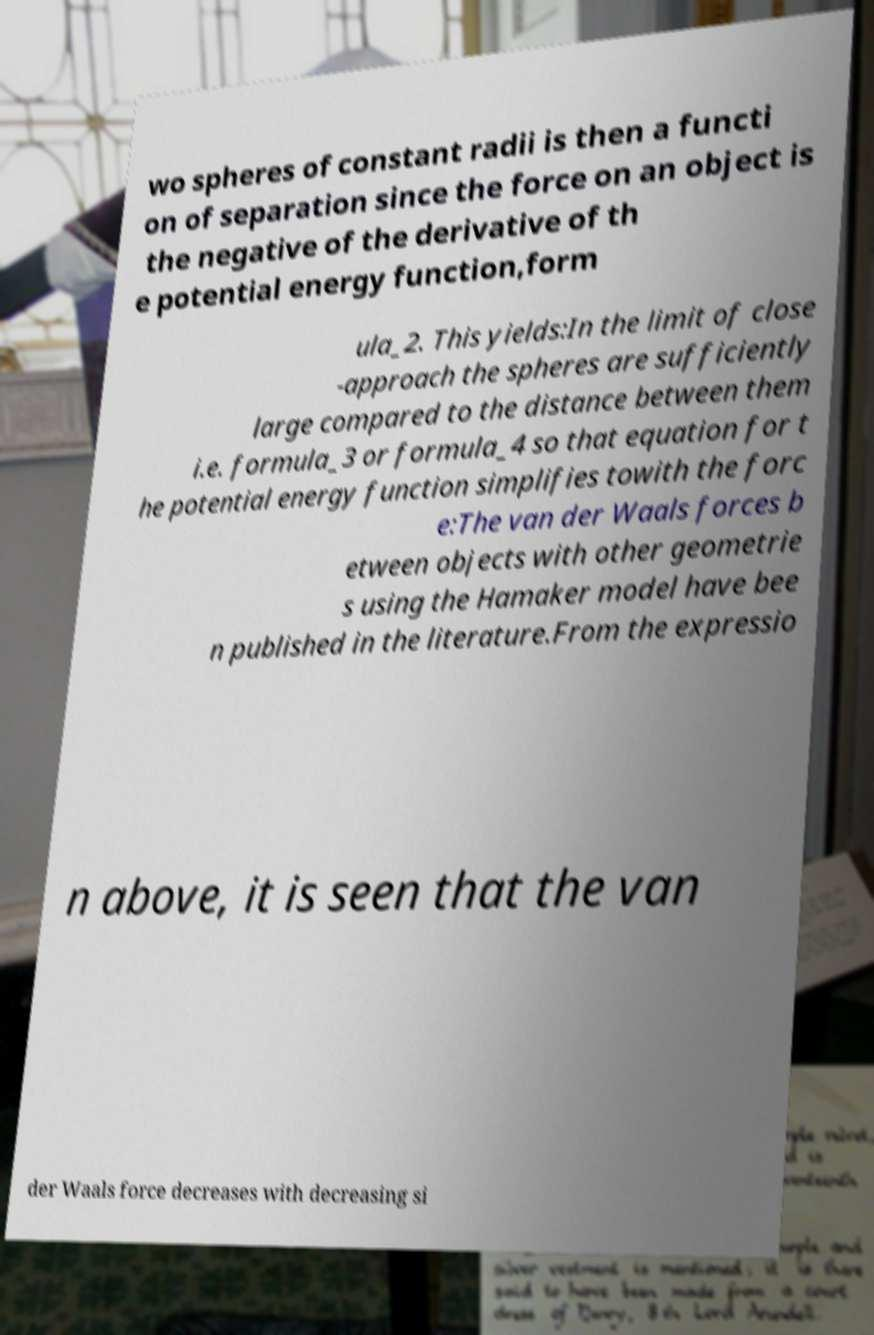Please identify and transcribe the text found in this image. wo spheres of constant radii is then a functi on of separation since the force on an object is the negative of the derivative of th e potential energy function,form ula_2. This yields:In the limit of close -approach the spheres are sufficiently large compared to the distance between them i.e. formula_3 or formula_4 so that equation for t he potential energy function simplifies towith the forc e:The van der Waals forces b etween objects with other geometrie s using the Hamaker model have bee n published in the literature.From the expressio n above, it is seen that the van der Waals force decreases with decreasing si 